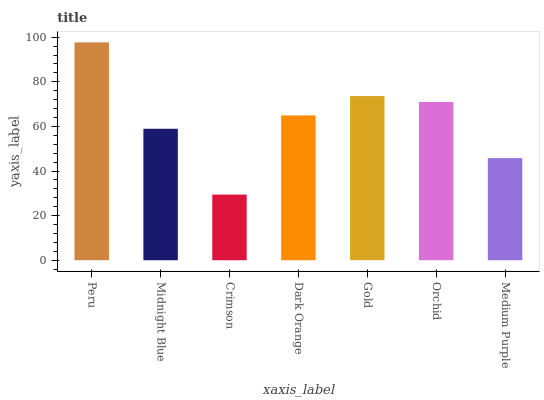Is Crimson the minimum?
Answer yes or no. Yes. Is Peru the maximum?
Answer yes or no. Yes. Is Midnight Blue the minimum?
Answer yes or no. No. Is Midnight Blue the maximum?
Answer yes or no. No. Is Peru greater than Midnight Blue?
Answer yes or no. Yes. Is Midnight Blue less than Peru?
Answer yes or no. Yes. Is Midnight Blue greater than Peru?
Answer yes or no. No. Is Peru less than Midnight Blue?
Answer yes or no. No. Is Dark Orange the high median?
Answer yes or no. Yes. Is Dark Orange the low median?
Answer yes or no. Yes. Is Gold the high median?
Answer yes or no. No. Is Medium Purple the low median?
Answer yes or no. No. 